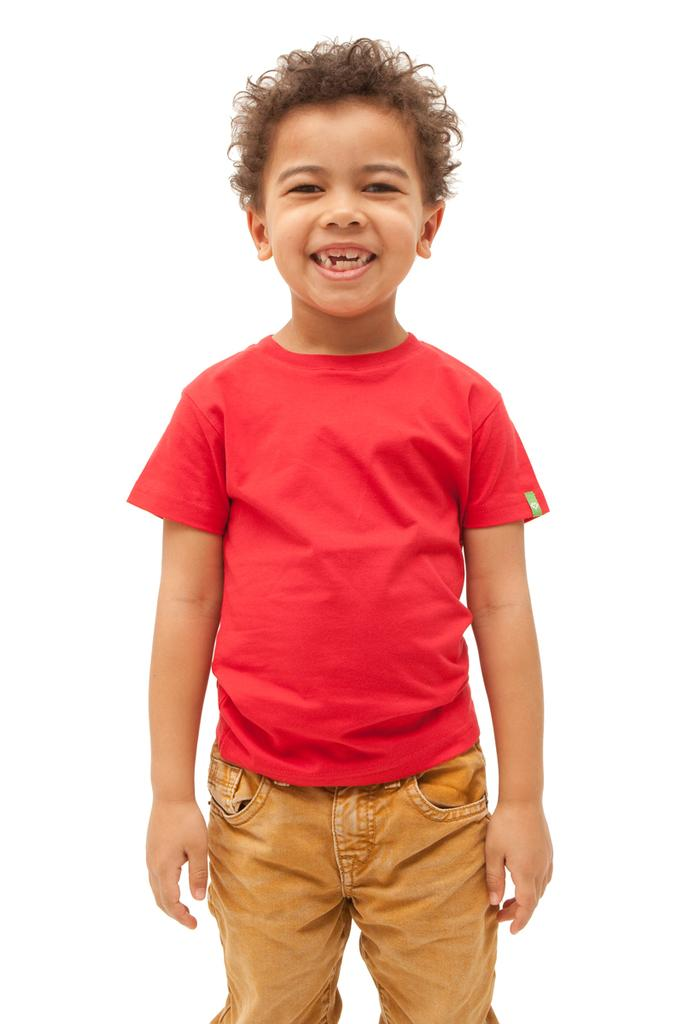Who is the main subject in the image? There is a boy in the image. What is the boy doing in the image? The boy is standing. What color is the boy's shirt in the image? The boy is wearing a red shirt. What color are the boy's pants in the image? The boy is wearing cream-colored pants. What type of beef is being served on a plate in the image? There is no beef or plate present in the image; it features a boy standing and wearing specific clothing. 